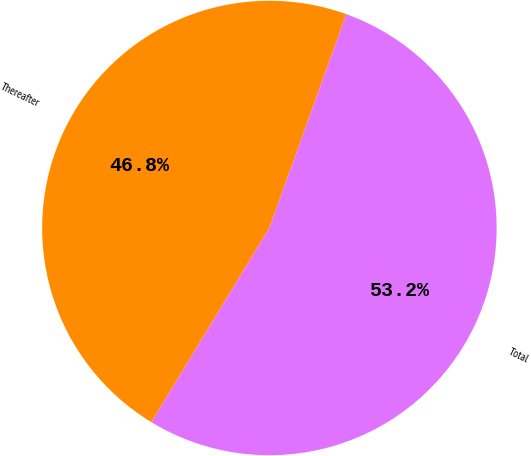Convert chart. <chart><loc_0><loc_0><loc_500><loc_500><pie_chart><fcel>Thereafter<fcel>Total<nl><fcel>46.81%<fcel>53.19%<nl></chart> 